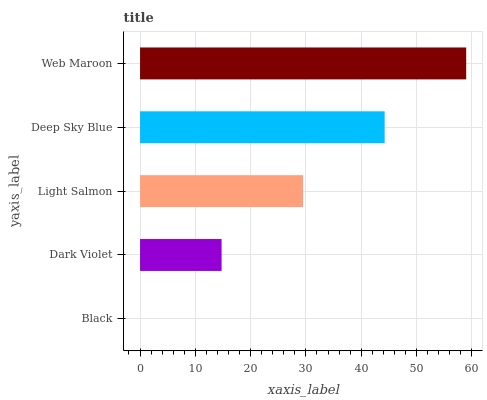Is Black the minimum?
Answer yes or no. Yes. Is Web Maroon the maximum?
Answer yes or no. Yes. Is Dark Violet the minimum?
Answer yes or no. No. Is Dark Violet the maximum?
Answer yes or no. No. Is Dark Violet greater than Black?
Answer yes or no. Yes. Is Black less than Dark Violet?
Answer yes or no. Yes. Is Black greater than Dark Violet?
Answer yes or no. No. Is Dark Violet less than Black?
Answer yes or no. No. Is Light Salmon the high median?
Answer yes or no. Yes. Is Light Salmon the low median?
Answer yes or no. Yes. Is Black the high median?
Answer yes or no. No. Is Black the low median?
Answer yes or no. No. 